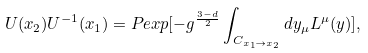Convert formula to latex. <formula><loc_0><loc_0><loc_500><loc_500>U ( x _ { 2 } ) U ^ { - 1 } ( x _ { 1 } ) = P e x p [ - g ^ { \frac { 3 - d } { 2 } } \int _ { C _ { x _ { 1 } \to x _ { 2 } } } d y _ { \mu } L ^ { \mu } ( y ) ] ,</formula> 